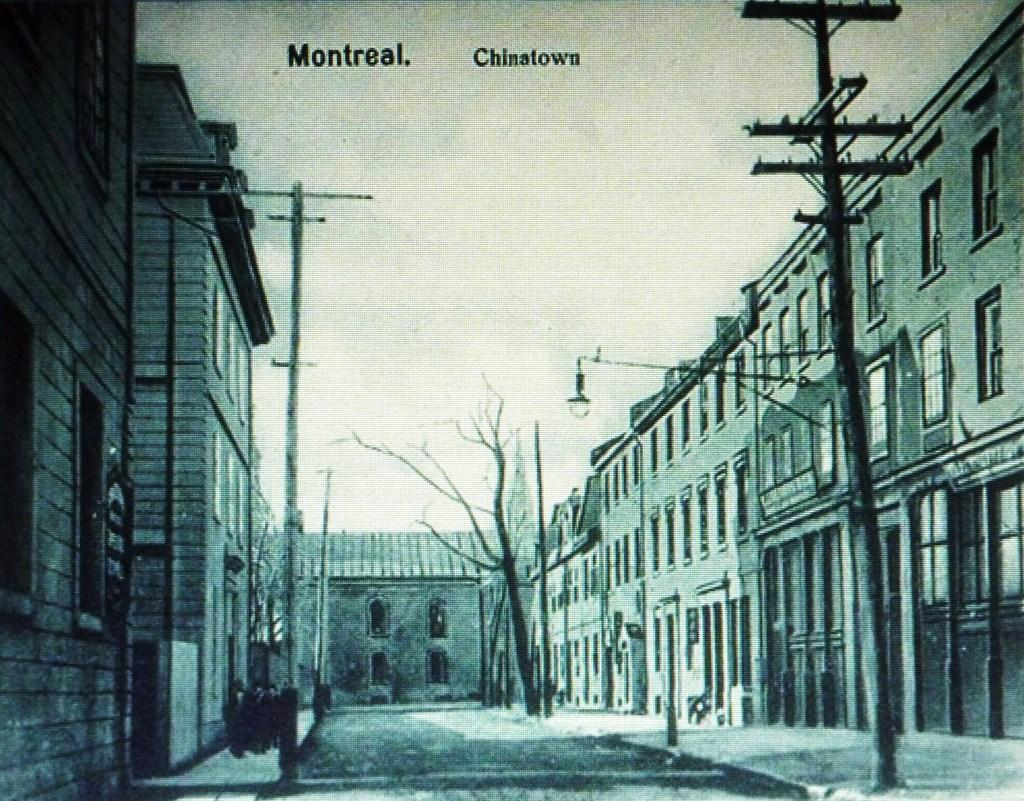What type of picture is in the image? The image contains a black and white picture. What can be seen in the picture? There are buildings, poles, and bare trees in the picture. Can you describe the lighting in the picture? There is light in the picture. What else is visible in the picture? The sky is visible in the picture. Are there any words or letters in the picture? Yes, there is text written on the picture. What type of seed can be seen growing near the buildings in the image? There is no seed visible in the image; it only contains a black and white picture of buildings, poles, and bare trees. Can you smell the smoke coming from the chimneys of the buildings in the image? There is no indication of smoke or chimneys in the image, so it's not possible to determine if there is a smell. 